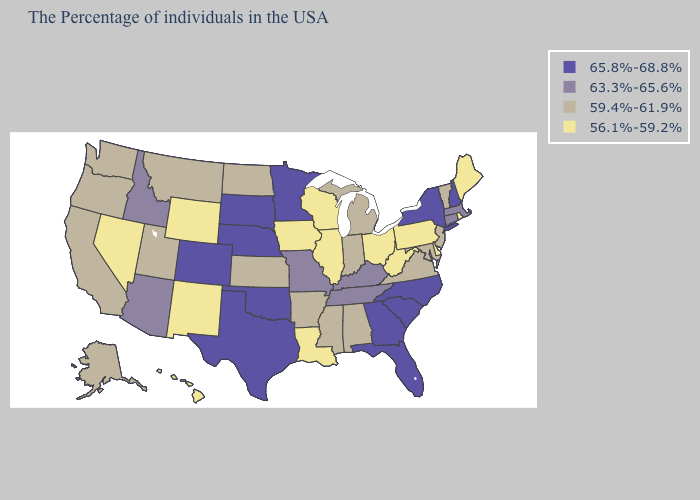What is the lowest value in the Northeast?
Give a very brief answer. 56.1%-59.2%. Does Delaware have the lowest value in the USA?
Give a very brief answer. Yes. Name the states that have a value in the range 59.4%-61.9%?
Answer briefly. Vermont, New Jersey, Maryland, Virginia, Michigan, Indiana, Alabama, Mississippi, Arkansas, Kansas, North Dakota, Utah, Montana, California, Washington, Oregon, Alaska. Which states have the lowest value in the West?
Write a very short answer. Wyoming, New Mexico, Nevada, Hawaii. Name the states that have a value in the range 65.8%-68.8%?
Short answer required. New Hampshire, New York, North Carolina, South Carolina, Florida, Georgia, Minnesota, Nebraska, Oklahoma, Texas, South Dakota, Colorado. What is the value of Delaware?
Write a very short answer. 56.1%-59.2%. Does Kentucky have a higher value than Arizona?
Answer briefly. No. What is the value of Connecticut?
Keep it brief. 63.3%-65.6%. What is the value of West Virginia?
Be succinct. 56.1%-59.2%. What is the value of Idaho?
Answer briefly. 63.3%-65.6%. Name the states that have a value in the range 63.3%-65.6%?
Write a very short answer. Massachusetts, Connecticut, Kentucky, Tennessee, Missouri, Arizona, Idaho. Does the first symbol in the legend represent the smallest category?
Keep it brief. No. Which states have the lowest value in the West?
Give a very brief answer. Wyoming, New Mexico, Nevada, Hawaii. Name the states that have a value in the range 56.1%-59.2%?
Be succinct. Maine, Rhode Island, Delaware, Pennsylvania, West Virginia, Ohio, Wisconsin, Illinois, Louisiana, Iowa, Wyoming, New Mexico, Nevada, Hawaii. What is the value of California?
Short answer required. 59.4%-61.9%. 